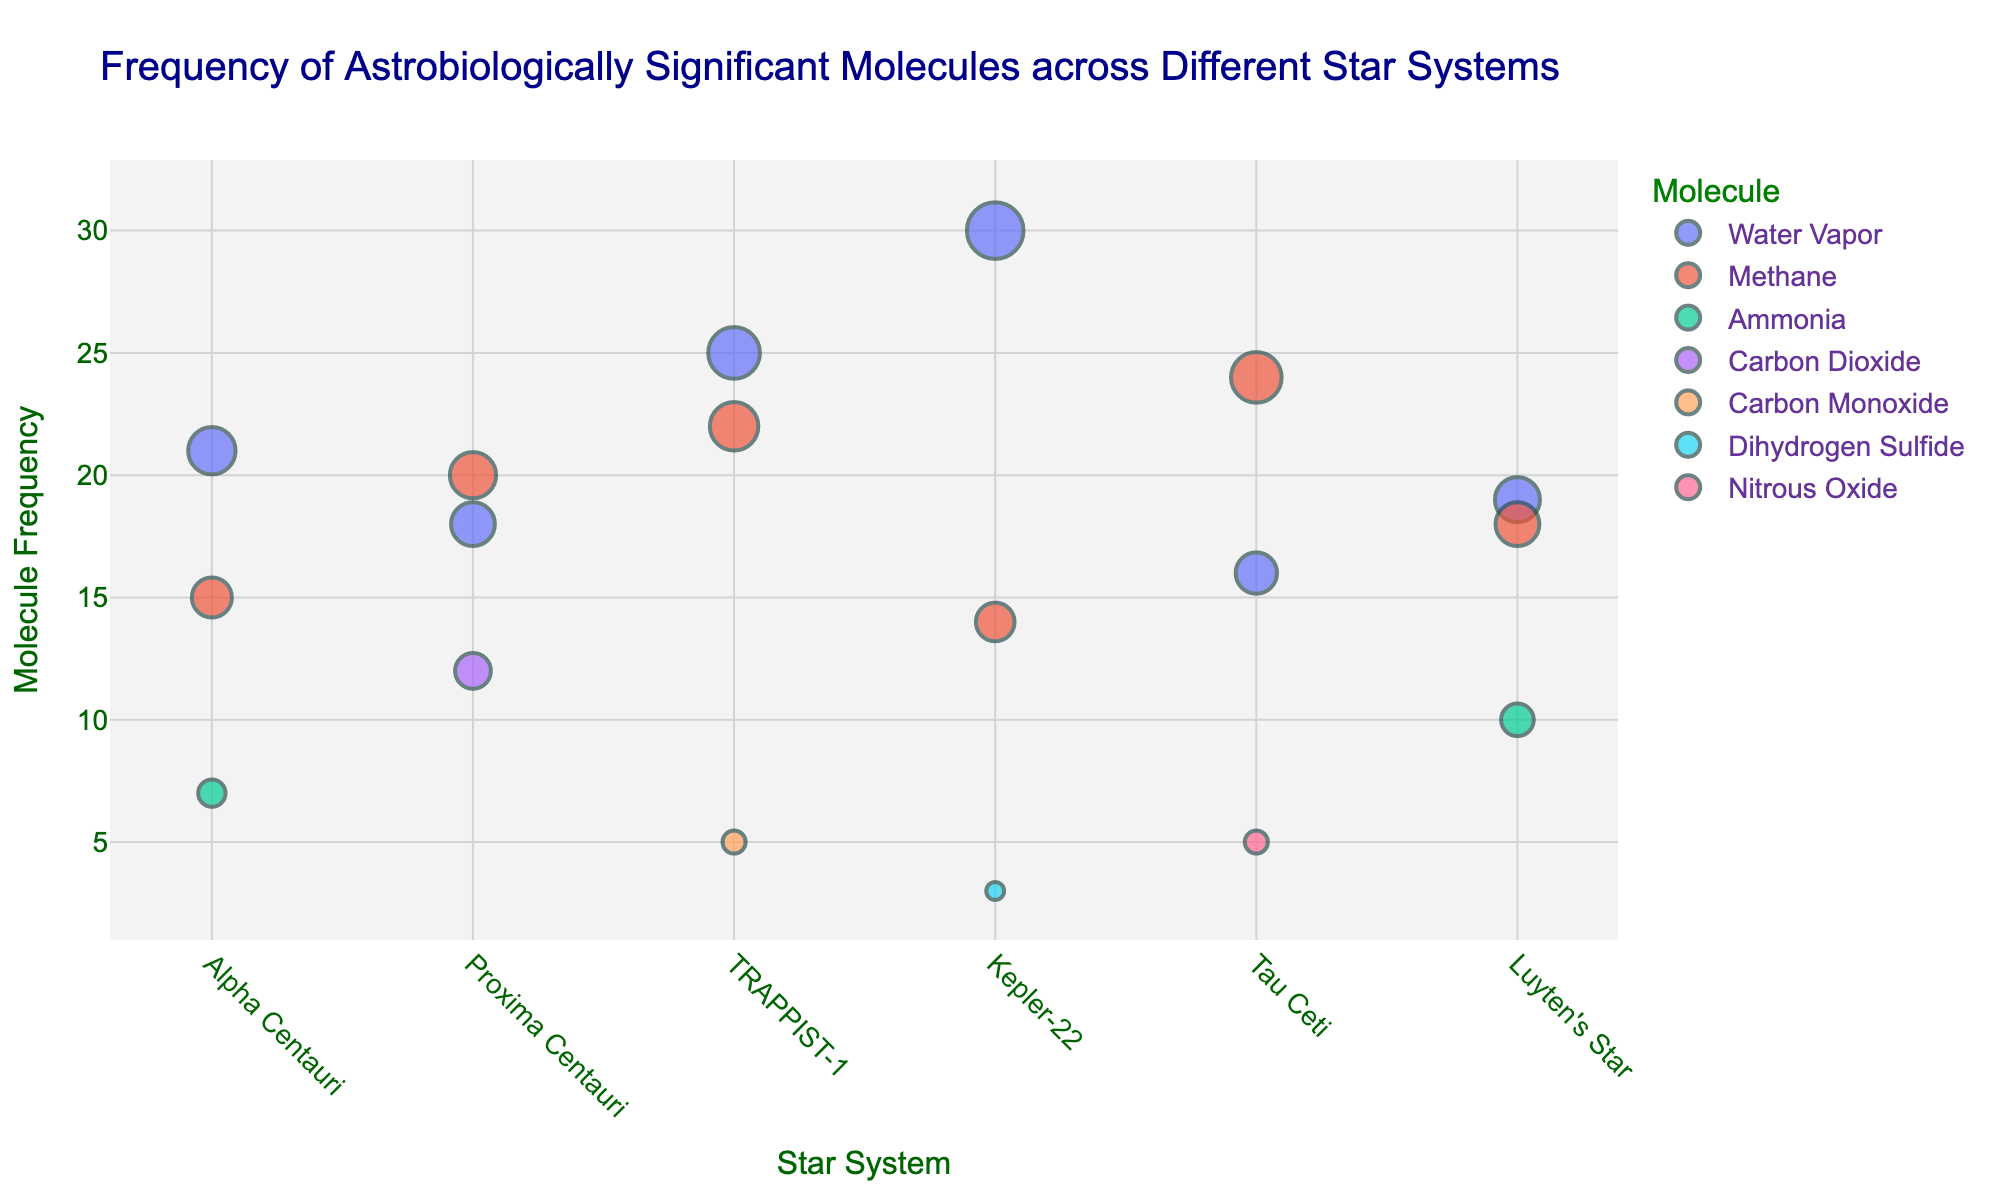What is the title of the plot? The title is usually displayed at the top of the plot. Here, it indicates the main subject of the representation in a succinct manner.
Answer: Frequency of Astrobiologically Significant Molecules across Different Star Systems What is the total frequency of Water Vapor detected across all star systems? To find the total frequency, sum the frequencies of Water Vapor from all star systems: 21 (Alpha Centauri) + 18 (Proxima Centauri) + 25 (TRAPPIST-1) + 30 (Kepler-22) + 16 (Tau Ceti) + 19 (Luyten's Star). 21 + 18 + 25 + 30 + 16 + 19 = 129
Answer: 129 Which star system has the highest frequency of Methane? Look for the star system with the highest Methane frequency by comparing the Methane values across all systems: 15 (Alpha Centauri), 20 (Proxima Centauri), 22 (TRAPPIST-1), 14 (Kepler-22), 24 (Tau Ceti), and 18 (Luyten's Star). The highest value is 24 in Tau Ceti.
Answer: Tau Ceti How many different types of molecules are represented in the plot? Count the unique molecules listed in the legend or indicated by the different colors of the points. There are: Water Vapor, Methane, Ammonia, Carbon Dioxide, Carbon Monoxide, Dihydrogen Sulfide, and Nitrous Oxide.
Answer: 7 Which molecule is found at a frequency of 30 in one star system? Observe the y-axis values and look for the molecule corresponding to the 30 frequency marker, then find the associated point's label.
Answer: Water Vapor What is the sum of the frequencies of all molecules in Alpha Centauri? Sum the frequencies of all molecules in Alpha Centauri: 21 (Water Vapor) + 15 (Methane) + 7 (Ammonia). 21 + 15 + 7 = 43
Answer: 43 Is there any star system where Ammonia is detected? If yes, which ones? Check the labels next to the corresponding data points for Ammonia. Ammonia has frequencies in Alpha Centauri (7) and Luyten's Star (10).
Answer: Alpha Centauri and Luyten's Star How does the frequency of Methane in Kepler-22 compare to that in Proxima Centauri? Locate the respective data points for Methane in both Kepler-22 (14) and Proxima Centauri (20) and compare the values. Methane is lower in Kepler-22 (14) than in Proxima Centauri (20).
Answer: Lower What are the frequencies of Carbon Dioxide and Carbon Monoxide in Proxima Centauri and TRAPPIST-1, respectively? Identify the data points for Carbon Dioxide in Proxima Centauri and Carbon Monoxide in TRAPPIST-1. Carbon Dioxide in Proxima Centauri has a frequency of 12, and Carbon Monoxide in TRAPPIST-1 has a frequency of 5.
Answer: 12 and 5 Does any molecule in TRAPPIST-1 have a higher frequency than any in Alpha Centauri? If so, which molecule and what is the frequency? Compare the frequencies in TRAPPIST-1 with those in Alpha Centauri. The highest frequencies in Alpha Centauri are: 21 (Water Vapor), 15 (Methane), and 7 (Ammonia). TRAPPIST-1 has Water Vapor (25) and Methane (22) with higher values than all in Alpha Centauri.
Answer: Water Vapor (25) and Methane (22) 